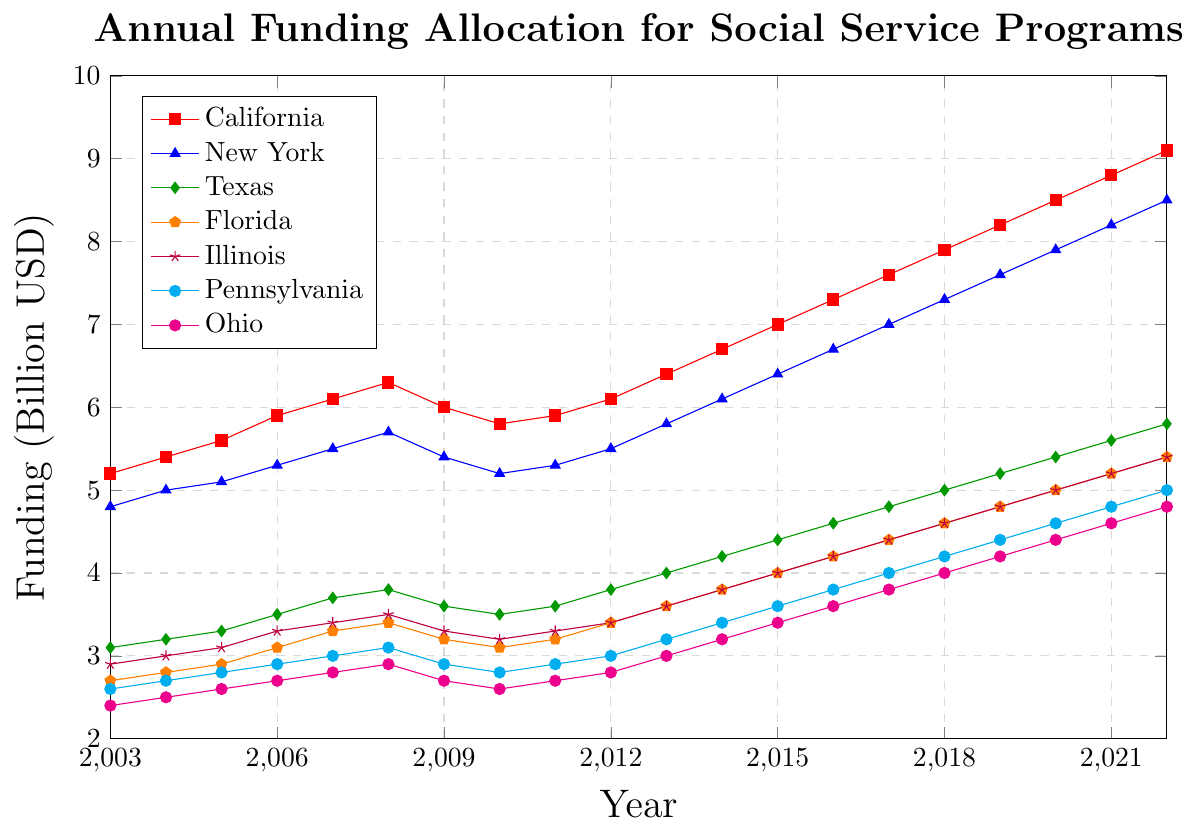Which state had the highest funding allocation in 2022? By looking at the y-axis which represents the funding in billion USD and tracing the lines for each state to the year 2022, the highest point corresponds to California.
Answer: California What was the funding difference between California and New York in 2010? In 2010, the funding for California was 5.8 billion USD and for New York it was 5.2 billion USD. The difference is 5.8 - 5.2 = 0.6 billion USD.
Answer: 0.6 billion USD Which state showed the most significant increase in funding from 2009 to 2013? By comparing the funding allocations in 2009 and 2013 for all states, California increased from 6.0 to 6.4 (0.4 billion), New York from 5.4 to 5.8 (0.4 billion), Texas from 3.6 to 4.0 (0.4 billion), Florida from 3.2 to 3.6 (0.4 billion), Illinois from 3.3 to 3.6 (0.3 billion), Pennsylvania from 2.9 to 3.2 (0.3 billion), and Ohio from 2.7 to 3.0 (0.3 billion). The most significant increases are all 0.4 billion USD, so several states (California, New York, Texas, Florida) showed the largest increase.
Answer: Several states (California, New York, Texas, Florida) Between which years did Ohio's funding see the most significant single-year increase? By tracing the Ohio funding line year by year, the most significant jump occurred from 2017 (3.8) to 2018 (4.0), which is an increase of 0.2 billion USD.
Answer: 2017 to 2018 What was the average funding for Texas from 2015 to 2020? Add the funding from 2015 to 2020: (4.4 + 4.6 + 4.8 + 5.0 + 5.2 + 5.4), sum them to get 29.4, then divide by 6 (the number of years). 29.4 / 6 = 4.9 billion USD.
Answer: 4.9 billion USD Which state had the lowest funding in 2006, and what was its value? By looking at the y-axis and tracing the points for each state back to 2006, Ohio had the lowest funding at 2.7 billion USD.
Answer: Ohio, 2.7 billion USD How does the funding for Pennsylvania in 2022 compare to its funding in 2003? In 2003, Pennsylvania's funding was 2.6 billion USD and in 2022, it was 5.0 billion USD. The funding in 2022 is higher by 2.4 billion USD.
Answer: 5.0 billion USD, higher by 2.4 billion USD 